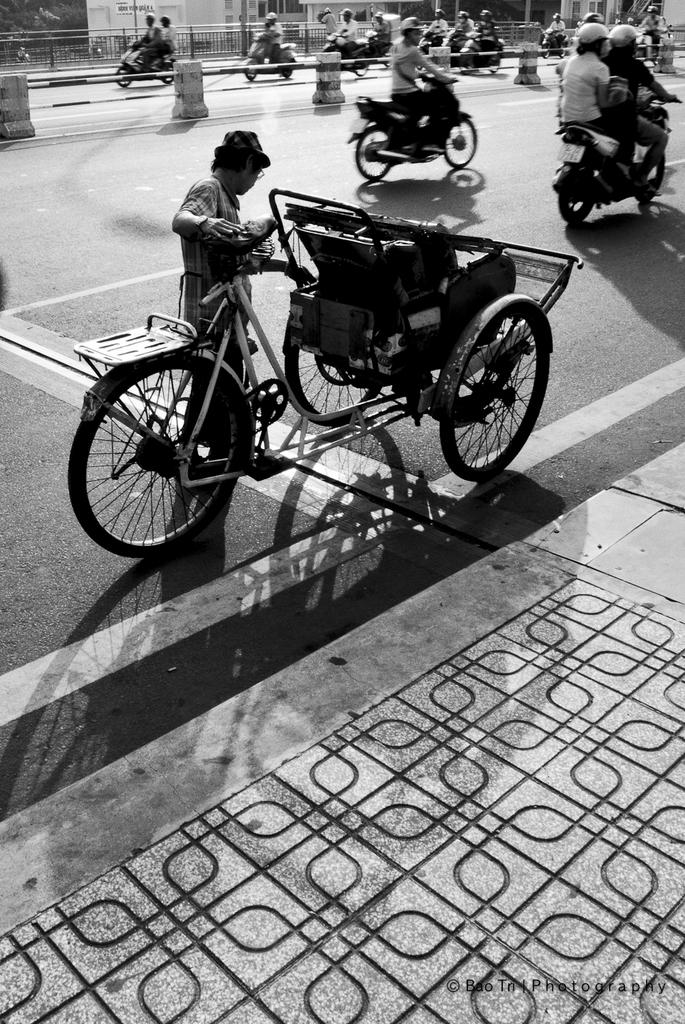What types of vehicles are being ridden by people in the image? There are people riding motorcycles and bicycles in the image. What can be seen in the background of the image? There is a fence in the image. Can you see any animals at the zoo in the image? There is no zoo or animals present in the image; it features people riding motorcycles and bicycles with a fence in the background. 